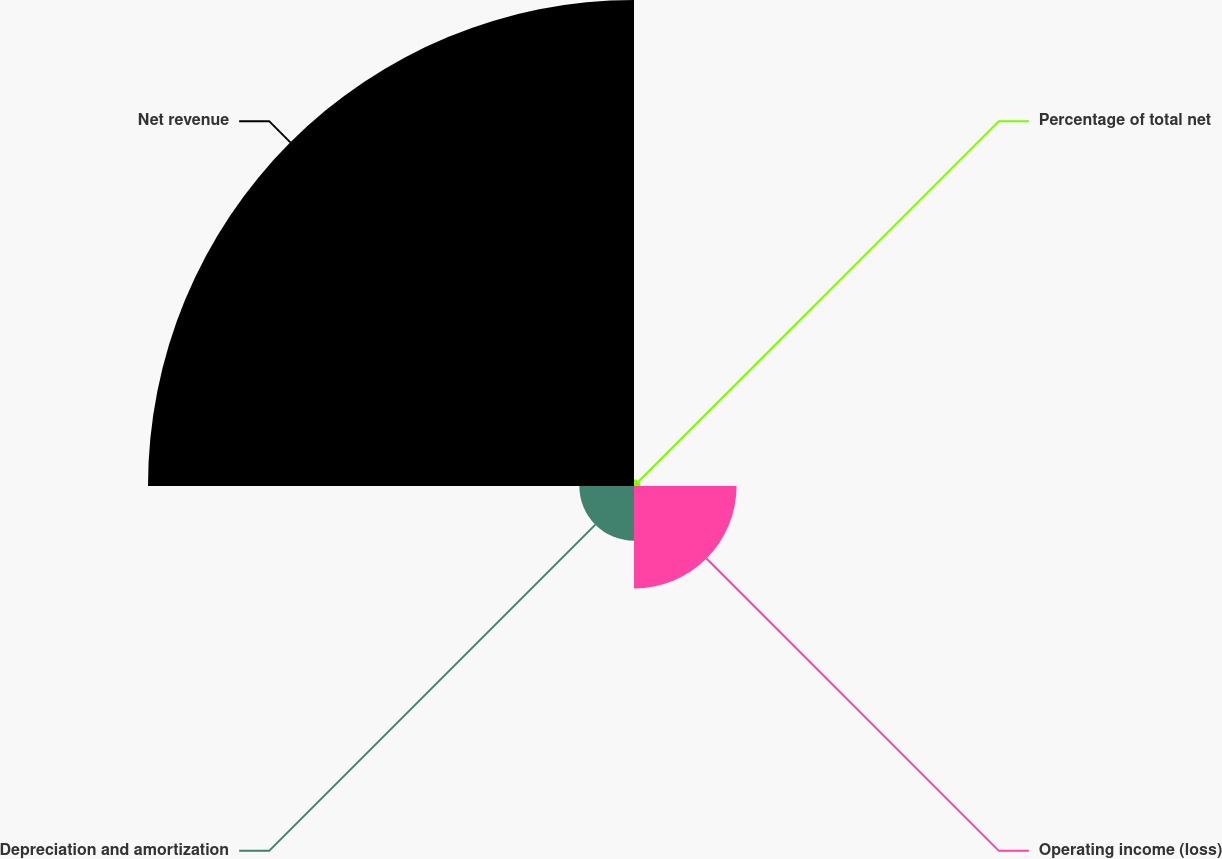Convert chart to OTSL. <chart><loc_0><loc_0><loc_500><loc_500><pie_chart><fcel>Percentage of total net<fcel>Operating income (loss)<fcel>Depreciation and amortization<fcel>Net revenue<nl><fcel>1.04%<fcel>15.78%<fcel>8.41%<fcel>74.77%<nl></chart> 